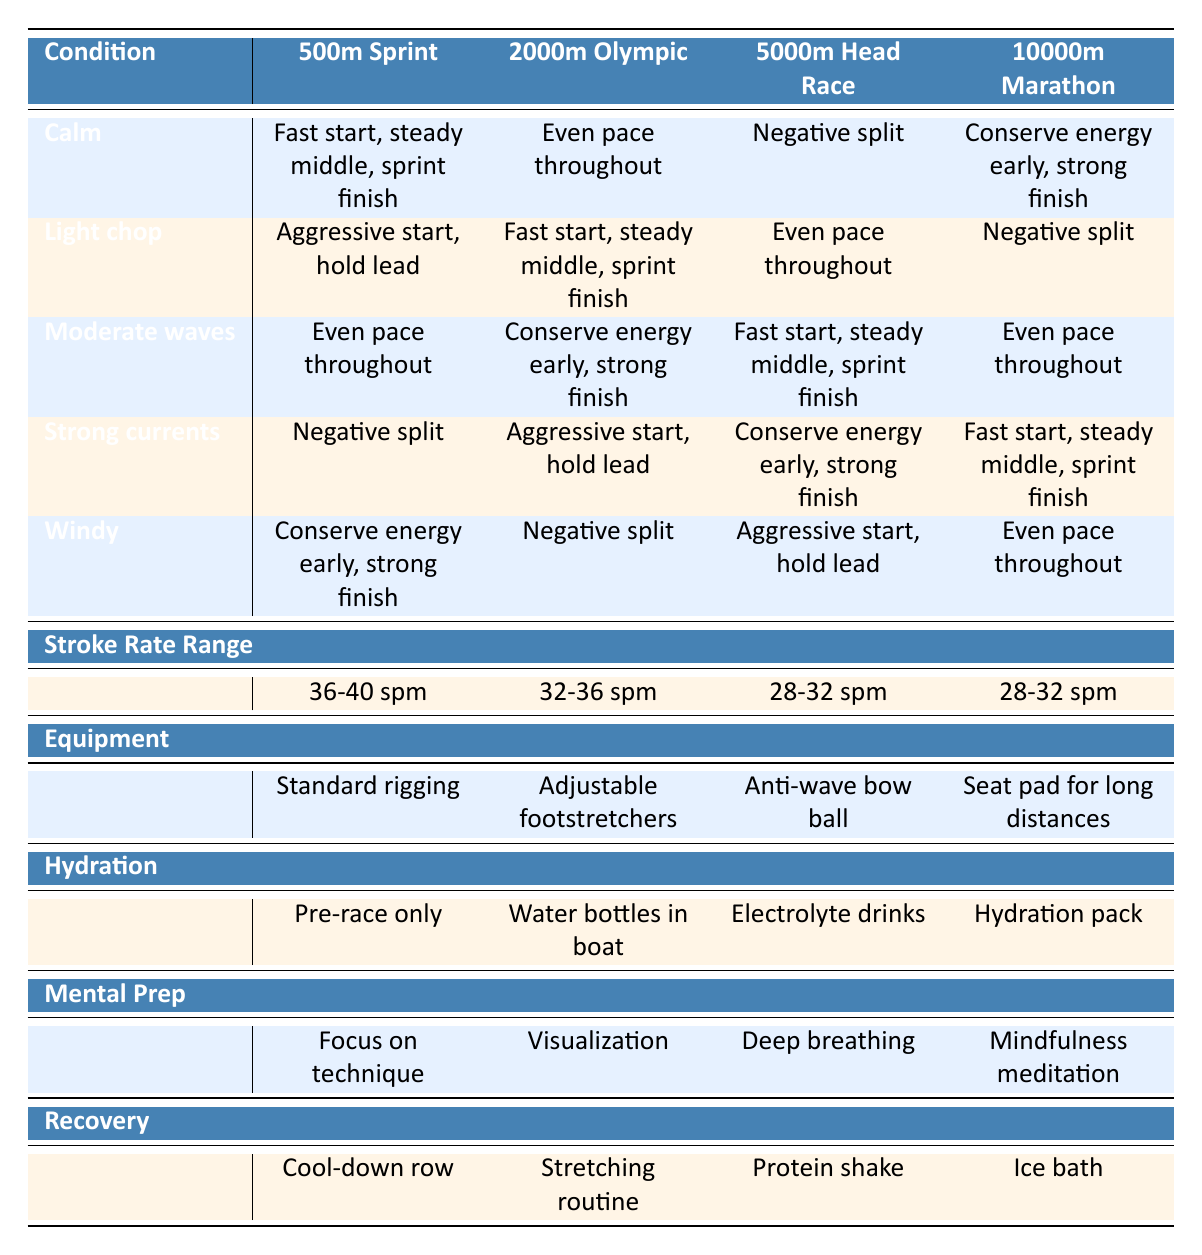What race strategy is recommended for a 500m sprint in calm water? According to the table, the strategy for a 500m sprint in calm water is "Fast start, steady middle, sprint finish."
Answer: Fast start, steady middle, sprint finish Is there any race distance where the strategy is to conserve energy early and have a strong finish? Yes, the strategy to conserve energy early and finish strong is recommended for the 10000m marathon in calm water.
Answer: Yes What stroke rate range is suggested for the 2000m Olympic event in light chop conditions? The table indicates that the stroke rate range for the 2000m Olympic event in light chop is between 32-36 strokes per minute.
Answer: 32-36 spm How many different strategies are suggested for the 5000m head race? There are three different strategies suggested for the 5000m head race: negative split, fast start, steady middle, sprint finish, and even pace throughout.
Answer: Three strategies Which water condition suggests using a hydration pack, and for what race distance? The water condition is windy, and the hydration pack is suggested for the 10000m marathon race distance.
Answer: Windy, 10000m marathon If a race is in strong currents, which strategy should not be used for the 2000m Olympic event? The table does not recommend "Even pace throughout" for the 2000m Olympic race in strong currents; instead, it suggests "Aggressive start, hold lead."
Answer: Even pace throughout For moderate waves in a 10000m marathon, what equipment consideration is recommended? The recommended equipment consideration for moderate waves in a 10000m marathon is a seat pad for long distances.
Answer: Seat pad for long distances Is it true that "negative split" is the suggested strategy only for a 5000m head race? No, "negative split" is suggested for both the 2000m Olympic event in windy conditions and the 5000m head race as per the table.
Answer: No What is the suggested mental preparation technique for a 500m sprint? The table suggests focusing on technique as the mental preparation technique for a 500m sprint.
Answer: Focus on technique 